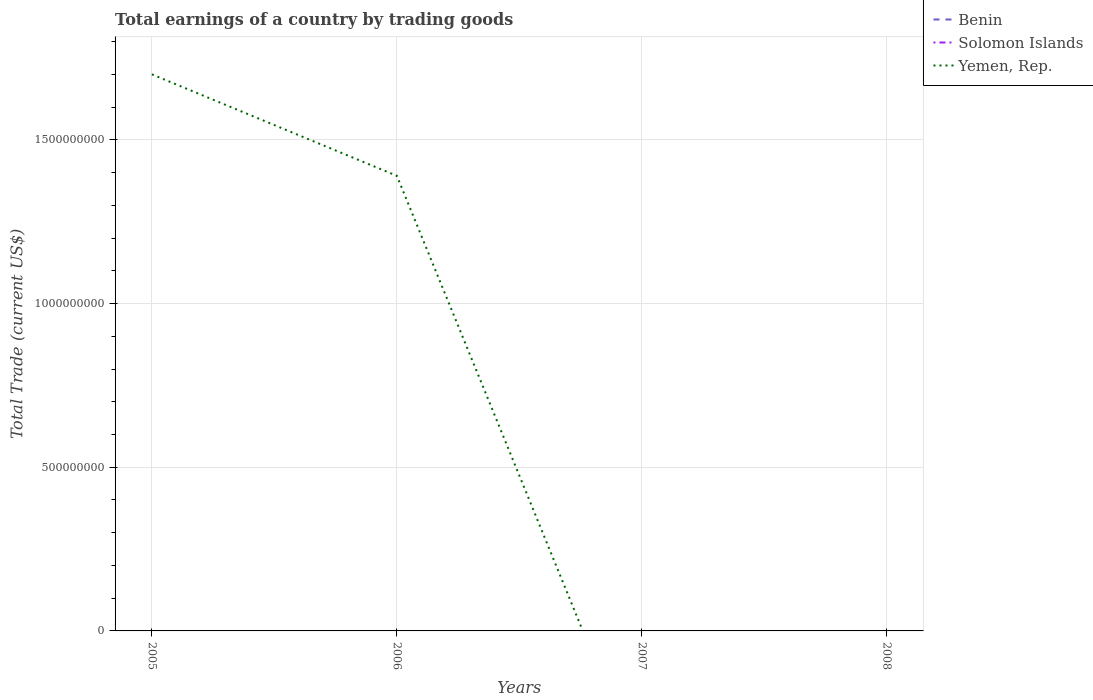Does the line corresponding to Benin intersect with the line corresponding to Yemen, Rep.?
Provide a succinct answer. No. Across all years, what is the maximum total earnings in Benin?
Your answer should be very brief. 0. What is the total total earnings in Yemen, Rep. in the graph?
Make the answer very short. 3.10e+08. What is the difference between the highest and the second highest total earnings in Yemen, Rep.?
Provide a succinct answer. 1.70e+09. What is the difference between the highest and the lowest total earnings in Solomon Islands?
Give a very brief answer. 0. Is the total earnings in Benin strictly greater than the total earnings in Yemen, Rep. over the years?
Your answer should be very brief. Yes. Are the values on the major ticks of Y-axis written in scientific E-notation?
Give a very brief answer. No. Where does the legend appear in the graph?
Make the answer very short. Top right. What is the title of the graph?
Make the answer very short. Total earnings of a country by trading goods. Does "Qatar" appear as one of the legend labels in the graph?
Your response must be concise. No. What is the label or title of the Y-axis?
Provide a succinct answer. Total Trade (current US$). What is the Total Trade (current US$) in Solomon Islands in 2005?
Offer a very short reply. 0. What is the Total Trade (current US$) in Yemen, Rep. in 2005?
Offer a very short reply. 1.70e+09. What is the Total Trade (current US$) of Benin in 2006?
Offer a very short reply. 0. What is the Total Trade (current US$) in Yemen, Rep. in 2006?
Provide a succinct answer. 1.39e+09. What is the Total Trade (current US$) in Benin in 2007?
Your answer should be very brief. 0. What is the Total Trade (current US$) in Solomon Islands in 2007?
Provide a succinct answer. 0. What is the Total Trade (current US$) of Yemen, Rep. in 2008?
Make the answer very short. 0. Across all years, what is the maximum Total Trade (current US$) in Yemen, Rep.?
Your answer should be compact. 1.70e+09. What is the total Total Trade (current US$) in Benin in the graph?
Your response must be concise. 0. What is the total Total Trade (current US$) in Solomon Islands in the graph?
Provide a short and direct response. 0. What is the total Total Trade (current US$) in Yemen, Rep. in the graph?
Offer a very short reply. 3.09e+09. What is the difference between the Total Trade (current US$) in Yemen, Rep. in 2005 and that in 2006?
Your response must be concise. 3.10e+08. What is the average Total Trade (current US$) in Benin per year?
Give a very brief answer. 0. What is the average Total Trade (current US$) of Yemen, Rep. per year?
Keep it short and to the point. 7.73e+08. What is the ratio of the Total Trade (current US$) in Yemen, Rep. in 2005 to that in 2006?
Your answer should be very brief. 1.22. What is the difference between the highest and the lowest Total Trade (current US$) in Yemen, Rep.?
Your answer should be compact. 1.70e+09. 